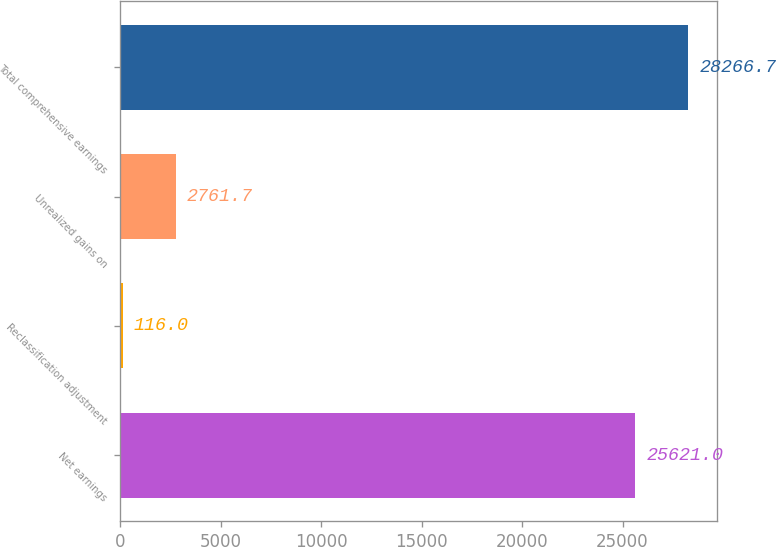Convert chart to OTSL. <chart><loc_0><loc_0><loc_500><loc_500><bar_chart><fcel>Net earnings<fcel>Reclassification adjustment<fcel>Unrealized gains on<fcel>Total comprehensive earnings<nl><fcel>25621<fcel>116<fcel>2761.7<fcel>28266.7<nl></chart> 